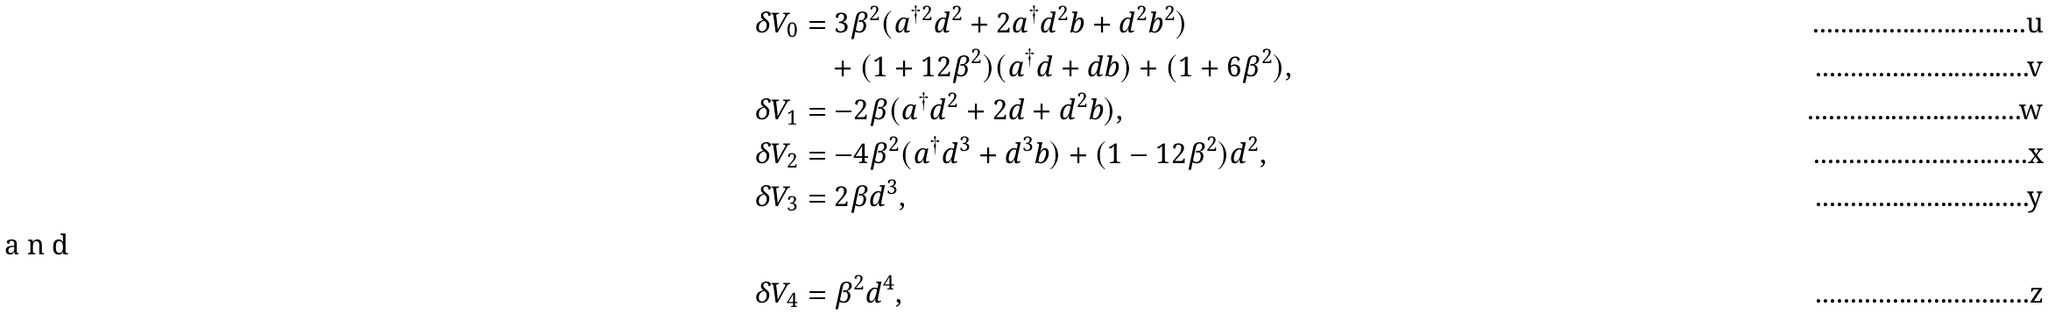<formula> <loc_0><loc_0><loc_500><loc_500>\delta V _ { 0 } & = 3 \beta ^ { 2 } ( a ^ { \dag 2 } d ^ { 2 } + 2 a ^ { \dag } d ^ { 2 } b + d ^ { 2 } b ^ { 2 } ) \\ & \quad + ( 1 + 1 2 \beta ^ { 2 } ) ( a ^ { \dag } d + d b ) + ( 1 + 6 \beta ^ { 2 } ) , \\ \delta V _ { 1 } & = - 2 \beta ( a ^ { \dag } d ^ { 2 } + 2 d + d ^ { 2 } b ) , \\ \delta V _ { 2 } & = - 4 \beta ^ { 2 } ( a ^ { \dag } d ^ { 3 } + d ^ { 3 } b ) + ( 1 - 1 2 \beta ^ { 2 } ) d ^ { 2 } , \\ \delta V _ { 3 } & = 2 \beta d ^ { 3 } , \\ \intertext { a n d } \delta V _ { 4 } & = \beta ^ { 2 } d ^ { 4 } ,</formula> 